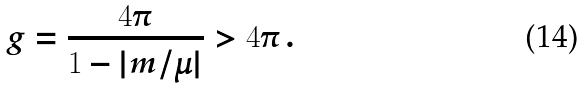<formula> <loc_0><loc_0><loc_500><loc_500>g = \frac { 4 \pi } { 1 - | m / \mu | } > 4 \pi \, .</formula> 